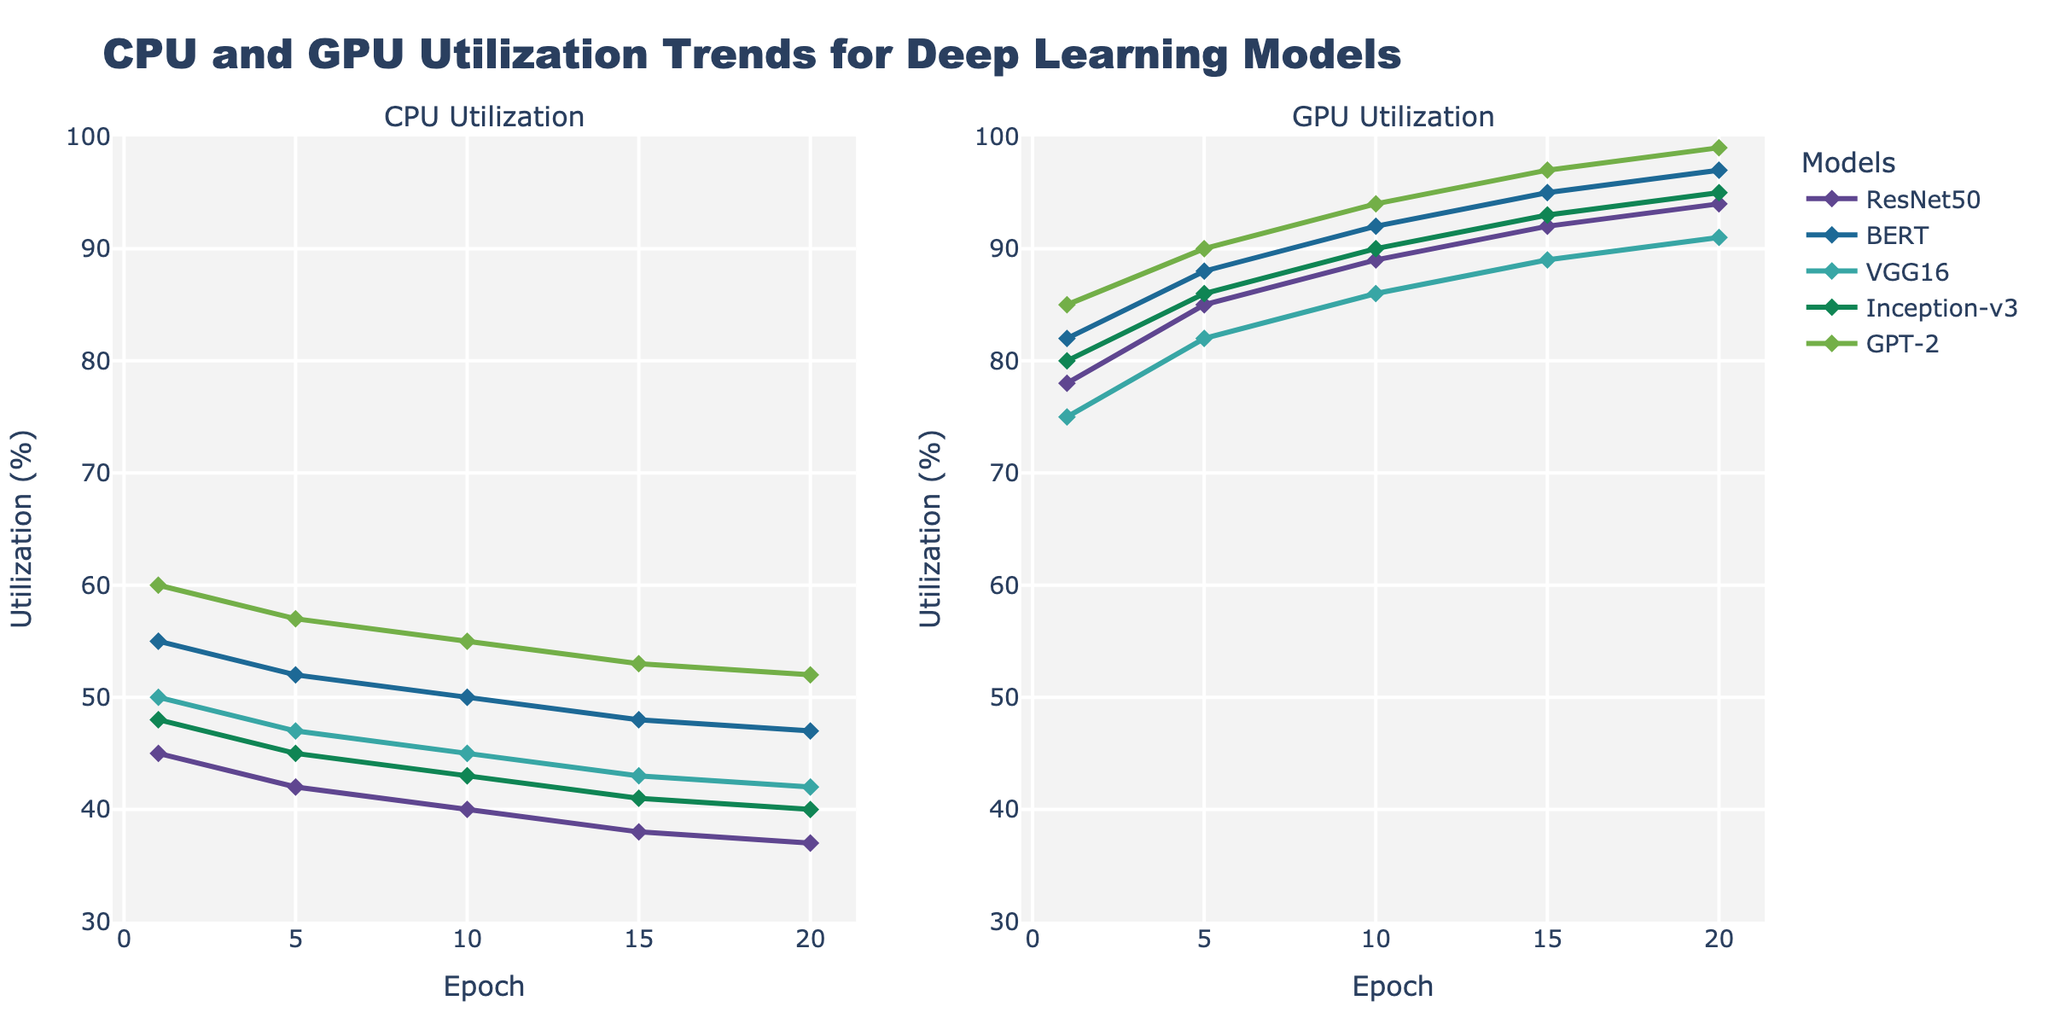Which model shows the highest initial CPU utilization? The initial CPU utilization is observed at epoch 1 for each model. By examining the CPU utilization values at epoch 1, GPT-2 has the highest value (60%) compared to ResNet50 (45%), BERT (55%), VGG16 (50%), and Inception-v3 (48%).
Answer: GPT-2 Which model had the steepest increase in GPU utilization from epoch 1 to epoch 20? To determine the steepest increase, calculate the difference in GPU utilization from epoch 1 to epoch 20 for each model. The values are: ResNet50 (94-78=16%), BERT (97-82=15%), VGG16 (91-75=16%), Inception-v3 (95-80=15%), GPT-2 (99-85=14%). ResNet50 and VGG16 have the same steepest increase of 16%.
Answer: ResNet50 and VGG16 What is the average CPU utilization for BERT from epoch 1 to epoch 20? Sum the CPU utilizations for BERT at each epoch and divide by the number of epochs: (55+52+50+48+47)/5 = 252/5 = 50.4%.
Answer: 50.4% Which model maintains the most consistent GPU utilization between epochs 5 and 15? Determine the variance in GPU utilization between epochs 5 and 15. For each model: ResNet50 (92-85=7%), BERT (95-88=7%), VGG16 (89-82=7%), Inception-v3 (93-86=7%), GPT-2 (97-90=7%). All models have a 7% change in GPU utilization over this interval, indicating they all maintain consistency.
Answer: All models Among all models, which one reaches the highest GPU utilization at epoch 20? Check the GPU utilization values at epoch 20 for each model: ResNet50 (94%), BERT (97%), VGG16 (91%), Inception-v3 (95%), GPT-2 (99%). GPT-2 has the highest GPU utilization at 99%.
Answer: GPT-2 What is the difference in CPU utilization between epochs 1 and 20 for VGG16? Find the CPU utilization for VGG16 at epoch 1 (50%) and at epoch 20 (42%), then compute the difference: 50 - 42 = 8%.
Answer: 8% Which model has the lowest initial GPU utilization, and what is its value? The initial GPU utilization is observed at epoch 1 for each model. From the data: ResNet50 (78%), BERT (82%), VGG16 (75%), Inception-v3 (80%), GPT-2 (85%). VGG16 has the lowest initial GPU utilization of 75%.
Answer: VGG16 By how much does the GPU utilization for GPT-2 increase from epoch 1 to epoch 15? Calculate the increase in GPU utilization for GPT-2 from epoch 1 (85%) to epoch 15 (97%), which is 97 - 85 = 12%.
Answer: 12% Which model showed the greatest decrease in CPU utilization from epoch 1 to epoch 20? Compute the decrease in CPU utilization for each model: ResNet50 (45-37=8%), BERT (55-47=8%), VGG16 (50-42=8%), Inception-v3 (48-40=8%), GPT-2 (60-52=8%). All models show the same decrease of 8%.
Answer: All models Compare the GPU utilization rate at epoch 10 between ResNet50 and Inception-v3. Which one is higher? Look at the GPU utilization values at epoch 10 for ResNet50 (89%) and Inception-v3 (90%). Inception-v3 is higher by 1%.
Answer: Inception-v3 